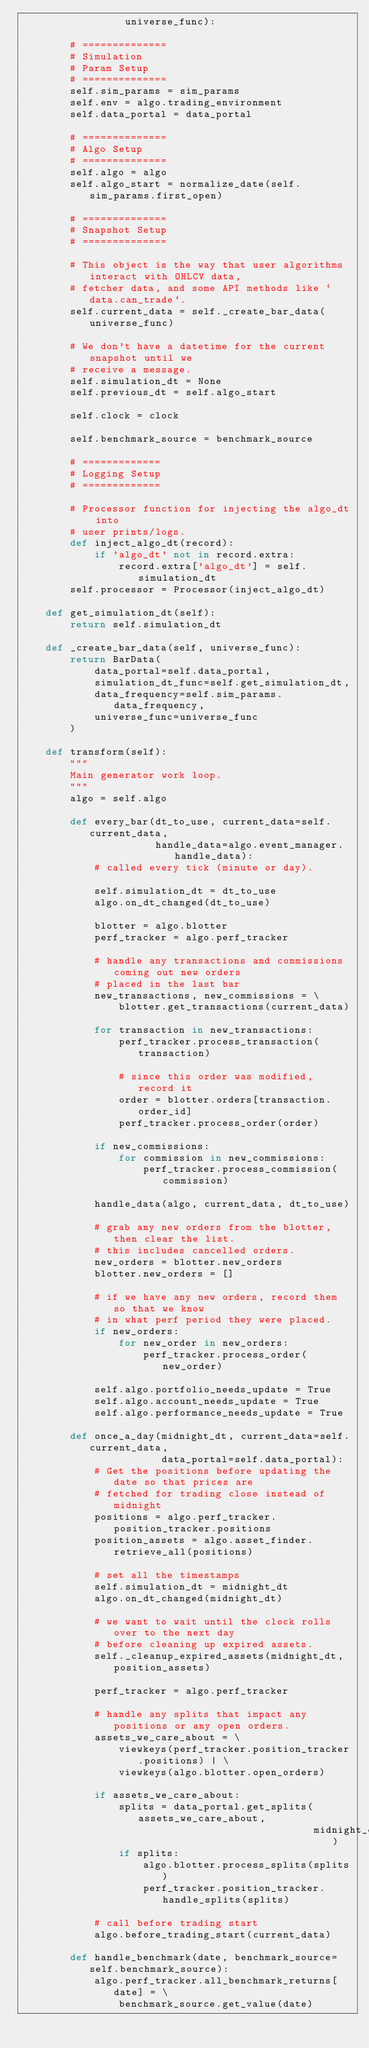<code> <loc_0><loc_0><loc_500><loc_500><_Python_>                 universe_func):

        # ==============
        # Simulation
        # Param Setup
        # ==============
        self.sim_params = sim_params
        self.env = algo.trading_environment
        self.data_portal = data_portal

        # ==============
        # Algo Setup
        # ==============
        self.algo = algo
        self.algo_start = normalize_date(self.sim_params.first_open)

        # ==============
        # Snapshot Setup
        # ==============

        # This object is the way that user algorithms interact with OHLCV data,
        # fetcher data, and some API methods like `data.can_trade`.
        self.current_data = self._create_bar_data(universe_func)

        # We don't have a datetime for the current snapshot until we
        # receive a message.
        self.simulation_dt = None
        self.previous_dt = self.algo_start

        self.clock = clock

        self.benchmark_source = benchmark_source

        # =============
        # Logging Setup
        # =============

        # Processor function for injecting the algo_dt into
        # user prints/logs.
        def inject_algo_dt(record):
            if 'algo_dt' not in record.extra:
                record.extra['algo_dt'] = self.simulation_dt
        self.processor = Processor(inject_algo_dt)

    def get_simulation_dt(self):
        return self.simulation_dt

    def _create_bar_data(self, universe_func):
        return BarData(
            data_portal=self.data_portal,
            simulation_dt_func=self.get_simulation_dt,
            data_frequency=self.sim_params.data_frequency,
            universe_func=universe_func
        )

    def transform(self):
        """
        Main generator work loop.
        """
        algo = self.algo

        def every_bar(dt_to_use, current_data=self.current_data,
                      handle_data=algo.event_manager.handle_data):
            # called every tick (minute or day).

            self.simulation_dt = dt_to_use
            algo.on_dt_changed(dt_to_use)

            blotter = algo.blotter
            perf_tracker = algo.perf_tracker

            # handle any transactions and commissions coming out new orders
            # placed in the last bar
            new_transactions, new_commissions = \
                blotter.get_transactions(current_data)

            for transaction in new_transactions:
                perf_tracker.process_transaction(transaction)

                # since this order was modified, record it
                order = blotter.orders[transaction.order_id]
                perf_tracker.process_order(order)

            if new_commissions:
                for commission in new_commissions:
                    perf_tracker.process_commission(commission)

            handle_data(algo, current_data, dt_to_use)

            # grab any new orders from the blotter, then clear the list.
            # this includes cancelled orders.
            new_orders = blotter.new_orders
            blotter.new_orders = []

            # if we have any new orders, record them so that we know
            # in what perf period they were placed.
            if new_orders:
                for new_order in new_orders:
                    perf_tracker.process_order(new_order)

            self.algo.portfolio_needs_update = True
            self.algo.account_needs_update = True
            self.algo.performance_needs_update = True

        def once_a_day(midnight_dt, current_data=self.current_data,
                       data_portal=self.data_portal):
            # Get the positions before updating the date so that prices are
            # fetched for trading close instead of midnight
            positions = algo.perf_tracker.position_tracker.positions
            position_assets = algo.asset_finder.retrieve_all(positions)

            # set all the timestamps
            self.simulation_dt = midnight_dt
            algo.on_dt_changed(midnight_dt)

            # we want to wait until the clock rolls over to the next day
            # before cleaning up expired assets.
            self._cleanup_expired_assets(midnight_dt, position_assets)

            perf_tracker = algo.perf_tracker

            # handle any splits that impact any positions or any open orders.
            assets_we_care_about = \
                viewkeys(perf_tracker.position_tracker.positions) | \
                viewkeys(algo.blotter.open_orders)

            if assets_we_care_about:
                splits = data_portal.get_splits(assets_we_care_about,
                                                midnight_dt)
                if splits:
                    algo.blotter.process_splits(splits)
                    perf_tracker.position_tracker.handle_splits(splits)

            # call before trading start
            algo.before_trading_start(current_data)

        def handle_benchmark(date, benchmark_source=self.benchmark_source):
            algo.perf_tracker.all_benchmark_returns[date] = \
                benchmark_source.get_value(date)
</code> 